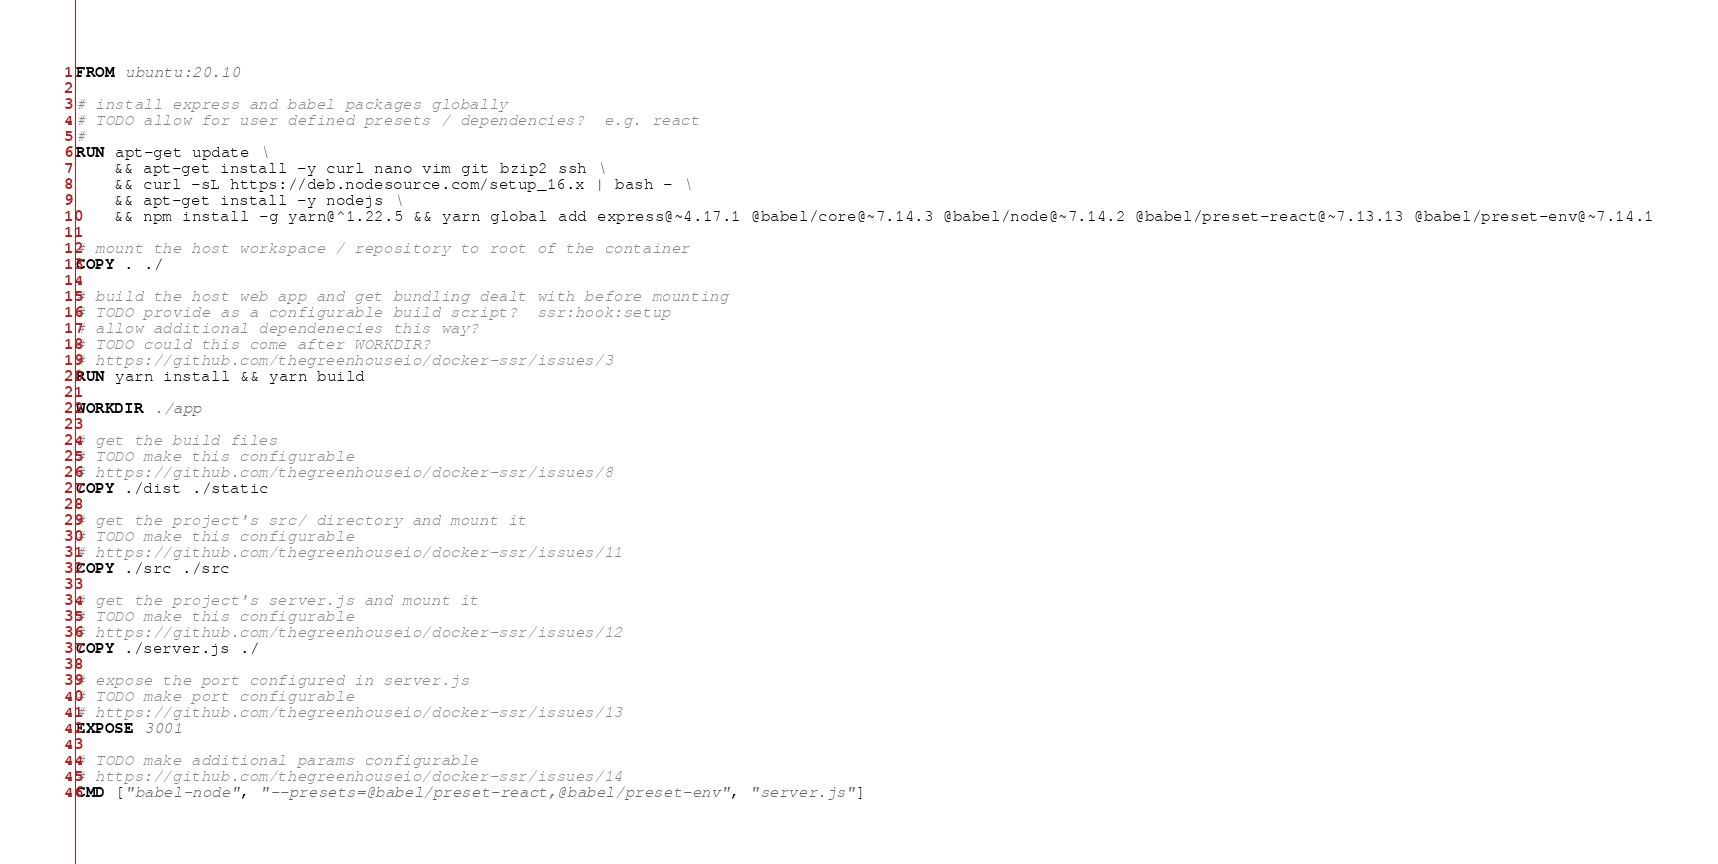Convert code to text. <code><loc_0><loc_0><loc_500><loc_500><_Dockerfile_>FROM ubuntu:20.10

# install express and babel packages globally
# TODO allow for user defined presets / dependencies?  e.g. react
# 
RUN apt-get update \ 
    && apt-get install -y curl nano vim git bzip2 ssh \
    && curl -sL https://deb.nodesource.com/setup_16.x | bash - \
    && apt-get install -y nodejs \
    && npm install -g yarn@^1.22.5 && yarn global add express@~4.17.1 @babel/core@~7.14.3 @babel/node@~7.14.2 @babel/preset-react@~7.13.13 @babel/preset-env@~7.14.1

# mount the host workspace / repository to root of the container
COPY . ./

# build the host web app and get bundling dealt with before mounting
# TODO provide as a configurable build script?  ssr:hook:setup
# allow additional dependenecies this way?
# TODO could this come after WORKDIR?
# https://github.com/thegreenhouseio/docker-ssr/issues/3
RUN yarn install && yarn build

WORKDIR ./app

# get the build files
# TODO make this configurable
# https://github.com/thegreenhouseio/docker-ssr/issues/8
COPY ./dist ./static

# get the project's src/ directory and mount it
# TODO make this configurable
# https://github.com/thegreenhouseio/docker-ssr/issues/11
COPY ./src ./src

# get the project's server.js and mount it
# TODO make this configurable
# https://github.com/thegreenhouseio/docker-ssr/issues/12
COPY ./server.js ./

# expose the port configured in server.js
# TODO make port configurable
# https://github.com/thegreenhouseio/docker-ssr/issues/13
EXPOSE 3001

# TODO make additional params configurable
# https://github.com/thegreenhouseio/docker-ssr/issues/14
CMD ["babel-node", "--presets=@babel/preset-react,@babel/preset-env", "server.js"]</code> 